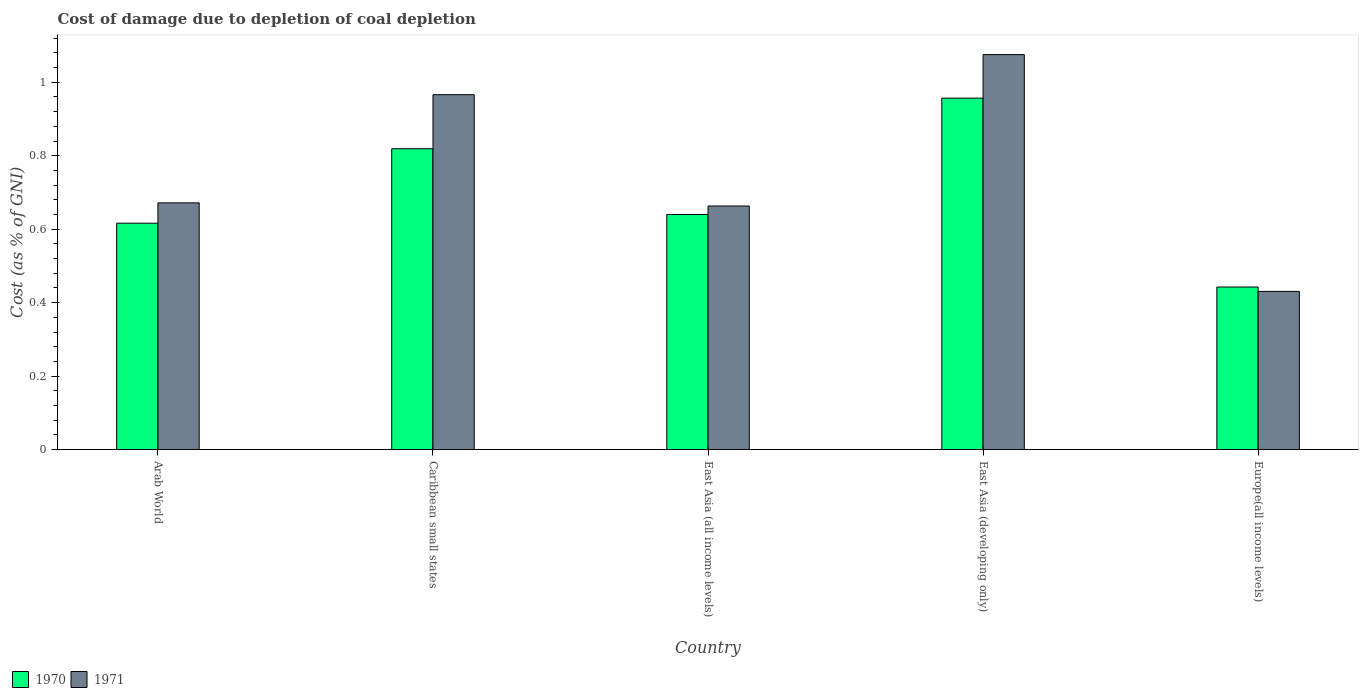How many different coloured bars are there?
Your response must be concise. 2. Are the number of bars per tick equal to the number of legend labels?
Offer a terse response. Yes. How many bars are there on the 4th tick from the right?
Provide a short and direct response. 2. What is the label of the 1st group of bars from the left?
Your answer should be compact. Arab World. In how many cases, is the number of bars for a given country not equal to the number of legend labels?
Provide a succinct answer. 0. What is the cost of damage caused due to coal depletion in 1970 in Caribbean small states?
Your answer should be compact. 0.82. Across all countries, what is the maximum cost of damage caused due to coal depletion in 1971?
Your answer should be very brief. 1.08. Across all countries, what is the minimum cost of damage caused due to coal depletion in 1971?
Provide a short and direct response. 0.43. In which country was the cost of damage caused due to coal depletion in 1971 maximum?
Your answer should be very brief. East Asia (developing only). In which country was the cost of damage caused due to coal depletion in 1971 minimum?
Your response must be concise. Europe(all income levels). What is the total cost of damage caused due to coal depletion in 1971 in the graph?
Your answer should be very brief. 3.81. What is the difference between the cost of damage caused due to coal depletion in 1970 in East Asia (all income levels) and that in East Asia (developing only)?
Make the answer very short. -0.32. What is the difference between the cost of damage caused due to coal depletion in 1970 in East Asia (developing only) and the cost of damage caused due to coal depletion in 1971 in Europe(all income levels)?
Your answer should be compact. 0.53. What is the average cost of damage caused due to coal depletion in 1970 per country?
Offer a very short reply. 0.69. What is the difference between the cost of damage caused due to coal depletion of/in 1971 and cost of damage caused due to coal depletion of/in 1970 in East Asia (all income levels)?
Make the answer very short. 0.02. What is the ratio of the cost of damage caused due to coal depletion in 1970 in East Asia (all income levels) to that in East Asia (developing only)?
Your answer should be compact. 0.67. Is the cost of damage caused due to coal depletion in 1970 in Arab World less than that in Caribbean small states?
Provide a short and direct response. Yes. Is the difference between the cost of damage caused due to coal depletion in 1971 in East Asia (all income levels) and Europe(all income levels) greater than the difference between the cost of damage caused due to coal depletion in 1970 in East Asia (all income levels) and Europe(all income levels)?
Provide a short and direct response. Yes. What is the difference between the highest and the second highest cost of damage caused due to coal depletion in 1970?
Your answer should be very brief. 0.14. What is the difference between the highest and the lowest cost of damage caused due to coal depletion in 1971?
Keep it short and to the point. 0.64. In how many countries, is the cost of damage caused due to coal depletion in 1970 greater than the average cost of damage caused due to coal depletion in 1970 taken over all countries?
Your answer should be compact. 2. Is the sum of the cost of damage caused due to coal depletion in 1970 in Arab World and East Asia (developing only) greater than the maximum cost of damage caused due to coal depletion in 1971 across all countries?
Ensure brevity in your answer.  Yes. What does the 2nd bar from the right in Europe(all income levels) represents?
Ensure brevity in your answer.  1970. Are all the bars in the graph horizontal?
Offer a very short reply. No. What is the difference between two consecutive major ticks on the Y-axis?
Offer a terse response. 0.2. Are the values on the major ticks of Y-axis written in scientific E-notation?
Your answer should be very brief. No. Does the graph contain any zero values?
Give a very brief answer. No. What is the title of the graph?
Make the answer very short. Cost of damage due to depletion of coal depletion. Does "2003" appear as one of the legend labels in the graph?
Make the answer very short. No. What is the label or title of the X-axis?
Provide a succinct answer. Country. What is the label or title of the Y-axis?
Offer a very short reply. Cost (as % of GNI). What is the Cost (as % of GNI) in 1970 in Arab World?
Your answer should be compact. 0.62. What is the Cost (as % of GNI) of 1971 in Arab World?
Give a very brief answer. 0.67. What is the Cost (as % of GNI) of 1970 in Caribbean small states?
Offer a terse response. 0.82. What is the Cost (as % of GNI) of 1971 in Caribbean small states?
Provide a succinct answer. 0.97. What is the Cost (as % of GNI) of 1970 in East Asia (all income levels)?
Give a very brief answer. 0.64. What is the Cost (as % of GNI) of 1971 in East Asia (all income levels)?
Make the answer very short. 0.66. What is the Cost (as % of GNI) in 1970 in East Asia (developing only)?
Your response must be concise. 0.96. What is the Cost (as % of GNI) of 1971 in East Asia (developing only)?
Make the answer very short. 1.08. What is the Cost (as % of GNI) of 1970 in Europe(all income levels)?
Provide a short and direct response. 0.44. What is the Cost (as % of GNI) of 1971 in Europe(all income levels)?
Provide a short and direct response. 0.43. Across all countries, what is the maximum Cost (as % of GNI) in 1970?
Your response must be concise. 0.96. Across all countries, what is the maximum Cost (as % of GNI) of 1971?
Your response must be concise. 1.08. Across all countries, what is the minimum Cost (as % of GNI) in 1970?
Your answer should be very brief. 0.44. Across all countries, what is the minimum Cost (as % of GNI) of 1971?
Your answer should be very brief. 0.43. What is the total Cost (as % of GNI) of 1970 in the graph?
Provide a short and direct response. 3.47. What is the total Cost (as % of GNI) of 1971 in the graph?
Ensure brevity in your answer.  3.81. What is the difference between the Cost (as % of GNI) of 1970 in Arab World and that in Caribbean small states?
Provide a short and direct response. -0.2. What is the difference between the Cost (as % of GNI) of 1971 in Arab World and that in Caribbean small states?
Your response must be concise. -0.29. What is the difference between the Cost (as % of GNI) of 1970 in Arab World and that in East Asia (all income levels)?
Offer a terse response. -0.02. What is the difference between the Cost (as % of GNI) in 1971 in Arab World and that in East Asia (all income levels)?
Ensure brevity in your answer.  0.01. What is the difference between the Cost (as % of GNI) in 1970 in Arab World and that in East Asia (developing only)?
Provide a short and direct response. -0.34. What is the difference between the Cost (as % of GNI) in 1971 in Arab World and that in East Asia (developing only)?
Give a very brief answer. -0.4. What is the difference between the Cost (as % of GNI) of 1970 in Arab World and that in Europe(all income levels)?
Ensure brevity in your answer.  0.17. What is the difference between the Cost (as % of GNI) in 1971 in Arab World and that in Europe(all income levels)?
Give a very brief answer. 0.24. What is the difference between the Cost (as % of GNI) of 1970 in Caribbean small states and that in East Asia (all income levels)?
Offer a very short reply. 0.18. What is the difference between the Cost (as % of GNI) in 1971 in Caribbean small states and that in East Asia (all income levels)?
Make the answer very short. 0.3. What is the difference between the Cost (as % of GNI) of 1970 in Caribbean small states and that in East Asia (developing only)?
Offer a terse response. -0.14. What is the difference between the Cost (as % of GNI) in 1971 in Caribbean small states and that in East Asia (developing only)?
Offer a very short reply. -0.11. What is the difference between the Cost (as % of GNI) in 1970 in Caribbean small states and that in Europe(all income levels)?
Make the answer very short. 0.38. What is the difference between the Cost (as % of GNI) of 1971 in Caribbean small states and that in Europe(all income levels)?
Your response must be concise. 0.54. What is the difference between the Cost (as % of GNI) in 1970 in East Asia (all income levels) and that in East Asia (developing only)?
Your answer should be very brief. -0.32. What is the difference between the Cost (as % of GNI) of 1971 in East Asia (all income levels) and that in East Asia (developing only)?
Your response must be concise. -0.41. What is the difference between the Cost (as % of GNI) of 1970 in East Asia (all income levels) and that in Europe(all income levels)?
Give a very brief answer. 0.2. What is the difference between the Cost (as % of GNI) of 1971 in East Asia (all income levels) and that in Europe(all income levels)?
Offer a very short reply. 0.23. What is the difference between the Cost (as % of GNI) of 1970 in East Asia (developing only) and that in Europe(all income levels)?
Offer a terse response. 0.51. What is the difference between the Cost (as % of GNI) in 1971 in East Asia (developing only) and that in Europe(all income levels)?
Keep it short and to the point. 0.64. What is the difference between the Cost (as % of GNI) in 1970 in Arab World and the Cost (as % of GNI) in 1971 in Caribbean small states?
Your answer should be very brief. -0.35. What is the difference between the Cost (as % of GNI) in 1970 in Arab World and the Cost (as % of GNI) in 1971 in East Asia (all income levels)?
Make the answer very short. -0.05. What is the difference between the Cost (as % of GNI) in 1970 in Arab World and the Cost (as % of GNI) in 1971 in East Asia (developing only)?
Your response must be concise. -0.46. What is the difference between the Cost (as % of GNI) in 1970 in Arab World and the Cost (as % of GNI) in 1971 in Europe(all income levels)?
Offer a very short reply. 0.19. What is the difference between the Cost (as % of GNI) in 1970 in Caribbean small states and the Cost (as % of GNI) in 1971 in East Asia (all income levels)?
Offer a very short reply. 0.16. What is the difference between the Cost (as % of GNI) in 1970 in Caribbean small states and the Cost (as % of GNI) in 1971 in East Asia (developing only)?
Provide a succinct answer. -0.26. What is the difference between the Cost (as % of GNI) of 1970 in Caribbean small states and the Cost (as % of GNI) of 1971 in Europe(all income levels)?
Provide a short and direct response. 0.39. What is the difference between the Cost (as % of GNI) of 1970 in East Asia (all income levels) and the Cost (as % of GNI) of 1971 in East Asia (developing only)?
Make the answer very short. -0.44. What is the difference between the Cost (as % of GNI) of 1970 in East Asia (all income levels) and the Cost (as % of GNI) of 1971 in Europe(all income levels)?
Make the answer very short. 0.21. What is the difference between the Cost (as % of GNI) of 1970 in East Asia (developing only) and the Cost (as % of GNI) of 1971 in Europe(all income levels)?
Offer a very short reply. 0.53. What is the average Cost (as % of GNI) of 1970 per country?
Offer a terse response. 0.69. What is the average Cost (as % of GNI) of 1971 per country?
Your response must be concise. 0.76. What is the difference between the Cost (as % of GNI) in 1970 and Cost (as % of GNI) in 1971 in Arab World?
Your response must be concise. -0.06. What is the difference between the Cost (as % of GNI) of 1970 and Cost (as % of GNI) of 1971 in Caribbean small states?
Provide a short and direct response. -0.15. What is the difference between the Cost (as % of GNI) in 1970 and Cost (as % of GNI) in 1971 in East Asia (all income levels)?
Keep it short and to the point. -0.02. What is the difference between the Cost (as % of GNI) in 1970 and Cost (as % of GNI) in 1971 in East Asia (developing only)?
Ensure brevity in your answer.  -0.12. What is the difference between the Cost (as % of GNI) of 1970 and Cost (as % of GNI) of 1971 in Europe(all income levels)?
Your response must be concise. 0.01. What is the ratio of the Cost (as % of GNI) in 1970 in Arab World to that in Caribbean small states?
Offer a very short reply. 0.75. What is the ratio of the Cost (as % of GNI) of 1971 in Arab World to that in Caribbean small states?
Your answer should be very brief. 0.7. What is the ratio of the Cost (as % of GNI) in 1970 in Arab World to that in East Asia (all income levels)?
Keep it short and to the point. 0.96. What is the ratio of the Cost (as % of GNI) of 1971 in Arab World to that in East Asia (all income levels)?
Your answer should be very brief. 1.01. What is the ratio of the Cost (as % of GNI) of 1970 in Arab World to that in East Asia (developing only)?
Your answer should be very brief. 0.64. What is the ratio of the Cost (as % of GNI) of 1971 in Arab World to that in East Asia (developing only)?
Give a very brief answer. 0.62. What is the ratio of the Cost (as % of GNI) of 1970 in Arab World to that in Europe(all income levels)?
Ensure brevity in your answer.  1.39. What is the ratio of the Cost (as % of GNI) of 1971 in Arab World to that in Europe(all income levels)?
Provide a succinct answer. 1.56. What is the ratio of the Cost (as % of GNI) in 1970 in Caribbean small states to that in East Asia (all income levels)?
Provide a short and direct response. 1.28. What is the ratio of the Cost (as % of GNI) in 1971 in Caribbean small states to that in East Asia (all income levels)?
Provide a succinct answer. 1.46. What is the ratio of the Cost (as % of GNI) in 1970 in Caribbean small states to that in East Asia (developing only)?
Keep it short and to the point. 0.86. What is the ratio of the Cost (as % of GNI) in 1971 in Caribbean small states to that in East Asia (developing only)?
Ensure brevity in your answer.  0.9. What is the ratio of the Cost (as % of GNI) in 1970 in Caribbean small states to that in Europe(all income levels)?
Provide a short and direct response. 1.85. What is the ratio of the Cost (as % of GNI) of 1971 in Caribbean small states to that in Europe(all income levels)?
Keep it short and to the point. 2.24. What is the ratio of the Cost (as % of GNI) of 1970 in East Asia (all income levels) to that in East Asia (developing only)?
Offer a terse response. 0.67. What is the ratio of the Cost (as % of GNI) of 1971 in East Asia (all income levels) to that in East Asia (developing only)?
Give a very brief answer. 0.62. What is the ratio of the Cost (as % of GNI) in 1970 in East Asia (all income levels) to that in Europe(all income levels)?
Make the answer very short. 1.45. What is the ratio of the Cost (as % of GNI) of 1971 in East Asia (all income levels) to that in Europe(all income levels)?
Your response must be concise. 1.54. What is the ratio of the Cost (as % of GNI) of 1970 in East Asia (developing only) to that in Europe(all income levels)?
Make the answer very short. 2.16. What is the ratio of the Cost (as % of GNI) in 1971 in East Asia (developing only) to that in Europe(all income levels)?
Offer a very short reply. 2.5. What is the difference between the highest and the second highest Cost (as % of GNI) of 1970?
Your response must be concise. 0.14. What is the difference between the highest and the second highest Cost (as % of GNI) of 1971?
Offer a terse response. 0.11. What is the difference between the highest and the lowest Cost (as % of GNI) of 1970?
Offer a terse response. 0.51. What is the difference between the highest and the lowest Cost (as % of GNI) of 1971?
Your answer should be very brief. 0.64. 